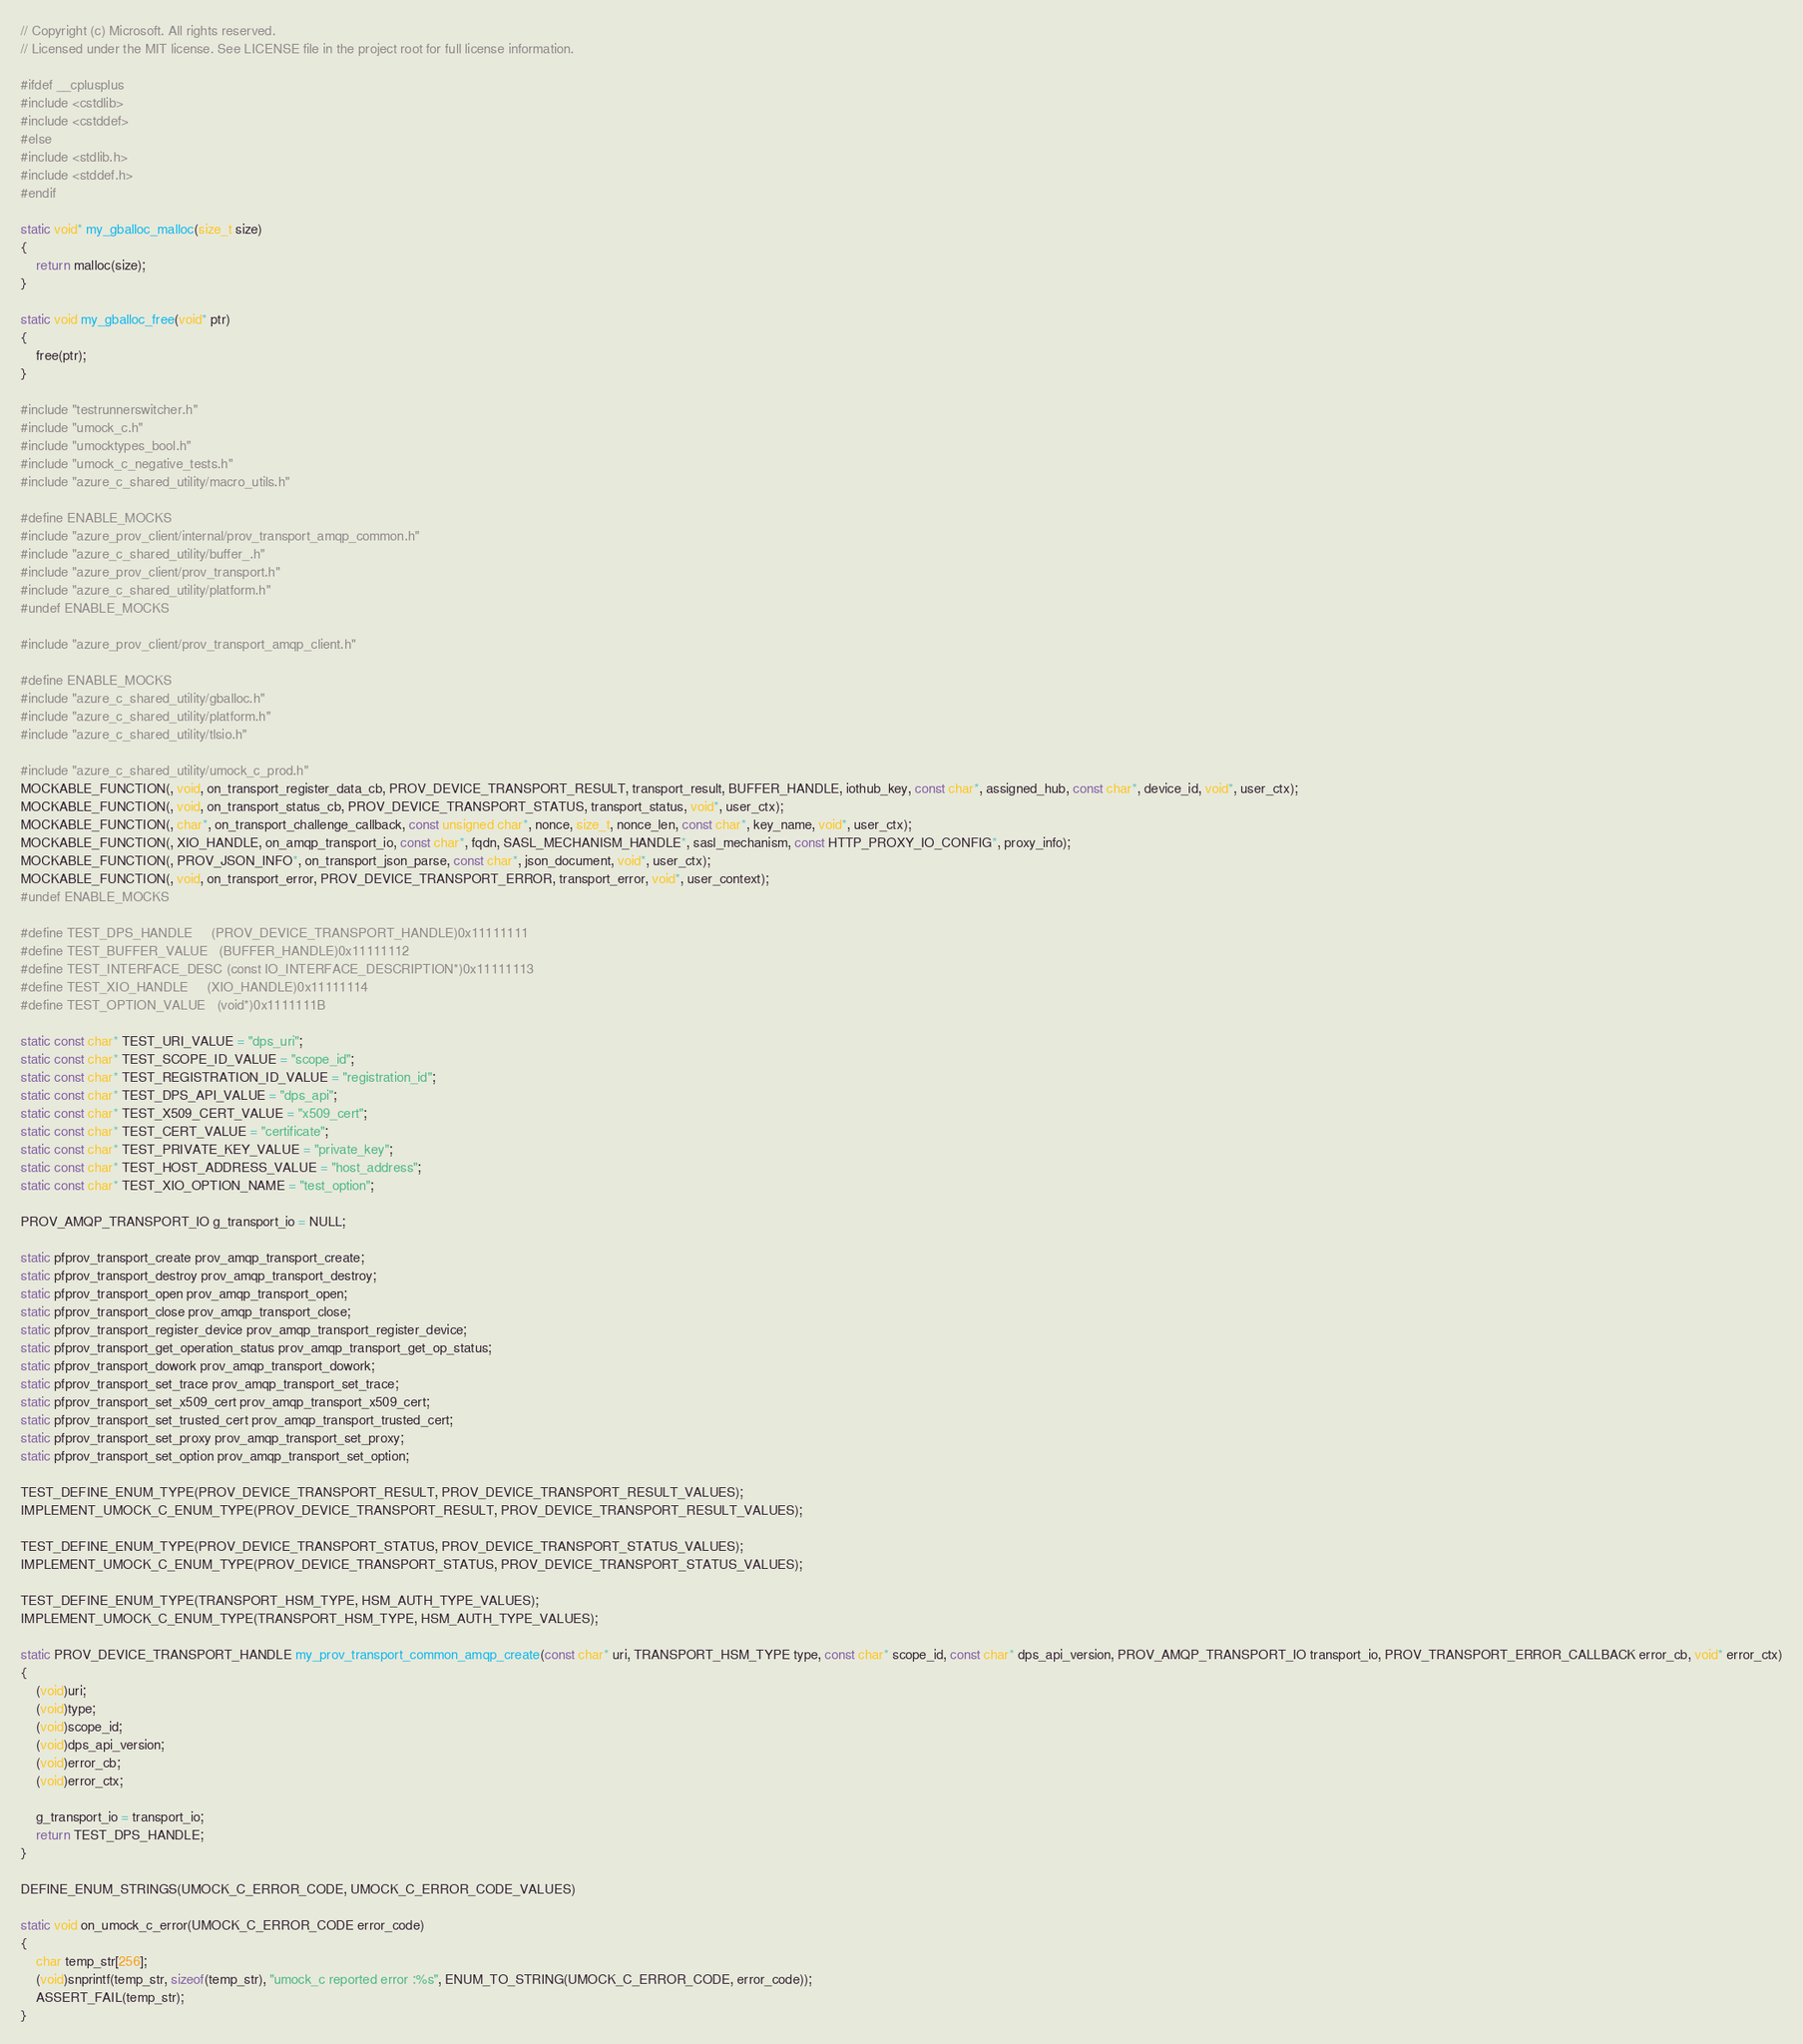Convert code to text. <code><loc_0><loc_0><loc_500><loc_500><_C_>// Copyright (c) Microsoft. All rights reserved.
// Licensed under the MIT license. See LICENSE file in the project root for full license information.

#ifdef __cplusplus
#include <cstdlib>
#include <cstddef>
#else
#include <stdlib.h>
#include <stddef.h>
#endif

static void* my_gballoc_malloc(size_t size)
{
    return malloc(size);
}

static void my_gballoc_free(void* ptr)
{
    free(ptr);
}

#include "testrunnerswitcher.h"
#include "umock_c.h"
#include "umocktypes_bool.h"
#include "umock_c_negative_tests.h"
#include "azure_c_shared_utility/macro_utils.h"

#define ENABLE_MOCKS
#include "azure_prov_client/internal/prov_transport_amqp_common.h"
#include "azure_c_shared_utility/buffer_.h"
#include "azure_prov_client/prov_transport.h"
#include "azure_c_shared_utility/platform.h"
#undef ENABLE_MOCKS

#include "azure_prov_client/prov_transport_amqp_client.h"

#define ENABLE_MOCKS
#include "azure_c_shared_utility/gballoc.h"
#include "azure_c_shared_utility/platform.h"
#include "azure_c_shared_utility/tlsio.h"

#include "azure_c_shared_utility/umock_c_prod.h"
MOCKABLE_FUNCTION(, void, on_transport_register_data_cb, PROV_DEVICE_TRANSPORT_RESULT, transport_result, BUFFER_HANDLE, iothub_key, const char*, assigned_hub, const char*, device_id, void*, user_ctx);
MOCKABLE_FUNCTION(, void, on_transport_status_cb, PROV_DEVICE_TRANSPORT_STATUS, transport_status, void*, user_ctx);
MOCKABLE_FUNCTION(, char*, on_transport_challenge_callback, const unsigned char*, nonce, size_t, nonce_len, const char*, key_name, void*, user_ctx);
MOCKABLE_FUNCTION(, XIO_HANDLE, on_amqp_transport_io, const char*, fqdn, SASL_MECHANISM_HANDLE*, sasl_mechanism, const HTTP_PROXY_IO_CONFIG*, proxy_info);
MOCKABLE_FUNCTION(, PROV_JSON_INFO*, on_transport_json_parse, const char*, json_document, void*, user_ctx);
MOCKABLE_FUNCTION(, void, on_transport_error, PROV_DEVICE_TRANSPORT_ERROR, transport_error, void*, user_context);
#undef ENABLE_MOCKS

#define TEST_DPS_HANDLE     (PROV_DEVICE_TRANSPORT_HANDLE)0x11111111
#define TEST_BUFFER_VALUE   (BUFFER_HANDLE)0x11111112
#define TEST_INTERFACE_DESC (const IO_INTERFACE_DESCRIPTION*)0x11111113
#define TEST_XIO_HANDLE     (XIO_HANDLE)0x11111114
#define TEST_OPTION_VALUE   (void*)0x1111111B

static const char* TEST_URI_VALUE = "dps_uri";
static const char* TEST_SCOPE_ID_VALUE = "scope_id";
static const char* TEST_REGISTRATION_ID_VALUE = "registration_id";
static const char* TEST_DPS_API_VALUE = "dps_api";
static const char* TEST_X509_CERT_VALUE = "x509_cert";
static const char* TEST_CERT_VALUE = "certificate";
static const char* TEST_PRIVATE_KEY_VALUE = "private_key";
static const char* TEST_HOST_ADDRESS_VALUE = "host_address";
static const char* TEST_XIO_OPTION_NAME = "test_option";

PROV_AMQP_TRANSPORT_IO g_transport_io = NULL;

static pfprov_transport_create prov_amqp_transport_create;
static pfprov_transport_destroy prov_amqp_transport_destroy;
static pfprov_transport_open prov_amqp_transport_open;
static pfprov_transport_close prov_amqp_transport_close;
static pfprov_transport_register_device prov_amqp_transport_register_device;
static pfprov_transport_get_operation_status prov_amqp_transport_get_op_status;
static pfprov_transport_dowork prov_amqp_transport_dowork;
static pfprov_transport_set_trace prov_amqp_transport_set_trace;
static pfprov_transport_set_x509_cert prov_amqp_transport_x509_cert;
static pfprov_transport_set_trusted_cert prov_amqp_transport_trusted_cert;
static pfprov_transport_set_proxy prov_amqp_transport_set_proxy;
static pfprov_transport_set_option prov_amqp_transport_set_option;

TEST_DEFINE_ENUM_TYPE(PROV_DEVICE_TRANSPORT_RESULT, PROV_DEVICE_TRANSPORT_RESULT_VALUES);
IMPLEMENT_UMOCK_C_ENUM_TYPE(PROV_DEVICE_TRANSPORT_RESULT, PROV_DEVICE_TRANSPORT_RESULT_VALUES);

TEST_DEFINE_ENUM_TYPE(PROV_DEVICE_TRANSPORT_STATUS, PROV_DEVICE_TRANSPORT_STATUS_VALUES);
IMPLEMENT_UMOCK_C_ENUM_TYPE(PROV_DEVICE_TRANSPORT_STATUS, PROV_DEVICE_TRANSPORT_STATUS_VALUES);

TEST_DEFINE_ENUM_TYPE(TRANSPORT_HSM_TYPE, HSM_AUTH_TYPE_VALUES);
IMPLEMENT_UMOCK_C_ENUM_TYPE(TRANSPORT_HSM_TYPE, HSM_AUTH_TYPE_VALUES);

static PROV_DEVICE_TRANSPORT_HANDLE my_prov_transport_common_amqp_create(const char* uri, TRANSPORT_HSM_TYPE type, const char* scope_id, const char* dps_api_version, PROV_AMQP_TRANSPORT_IO transport_io, PROV_TRANSPORT_ERROR_CALLBACK error_cb, void* error_ctx)
{
    (void)uri;
    (void)type;
    (void)scope_id;
    (void)dps_api_version;
    (void)error_cb;
    (void)error_ctx;

    g_transport_io = transport_io;
    return TEST_DPS_HANDLE;
}

DEFINE_ENUM_STRINGS(UMOCK_C_ERROR_CODE, UMOCK_C_ERROR_CODE_VALUES)

static void on_umock_c_error(UMOCK_C_ERROR_CODE error_code)
{
    char temp_str[256];
    (void)snprintf(temp_str, sizeof(temp_str), "umock_c reported error :%s", ENUM_TO_STRING(UMOCK_C_ERROR_CODE, error_code));
    ASSERT_FAIL(temp_str);
}
</code> 